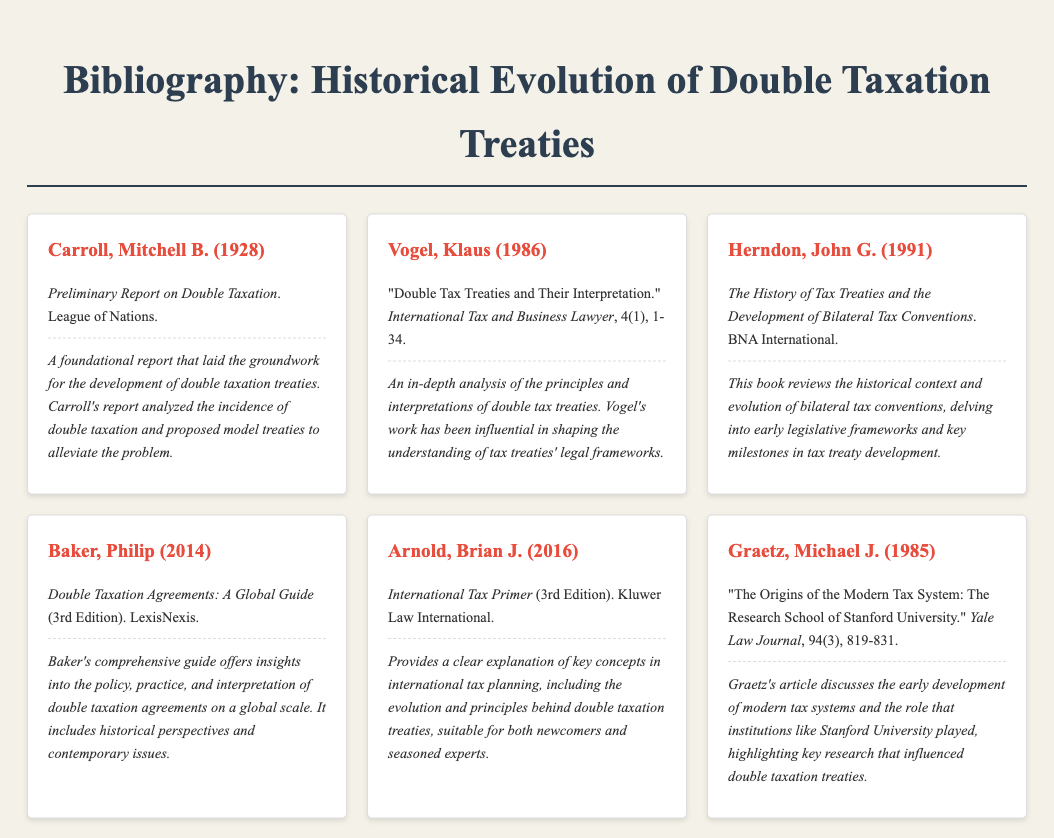What is the title of Carroll's 1928 work? The title of Carroll's work is given in the document and indicates a seminal contribution to the field of double taxation treaties.
Answer: Preliminary Report on Double Taxation What year did Vogel publish his analysis? The document lists the year of publication for Vogel's work, which provides context for its relevance in the evolution of tax treaties.
Answer: 1986 Who is the author of "The History of Tax Treaties and the Development of Bilateral Tax Conventions"? The author of this significant work on bilateral tax conventions is mentioned in the bibliography, providing insight into the scholarship in this area.
Answer: John G. Herndon What does Baker's 2014 guide focus on? The focus of Baker's guide is explicitly detailed in the document, indicating its relevance to practitioners and scholars alike.
Answer: Double taxation agreements Which edition of Arnold's book is referenced? The bibliography specifies the edition of Arnold's book which indicates the currency and depth of the information provided.
Answer: 3rd Edition What type of document is Graetz's work? The nature of Graetz's work is provided in the bibliography, categorizing it as part of legal scholarship on tax systems.
Answer: Article 